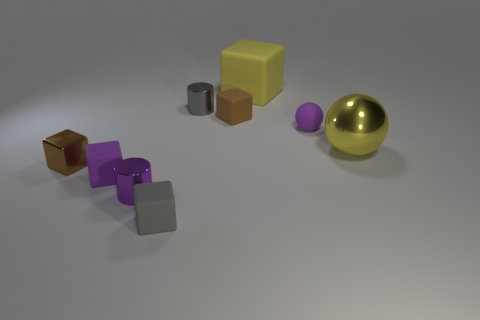Subtract all tiny purple rubber cubes. How many cubes are left? 4 Subtract all yellow blocks. How many blocks are left? 4 Subtract all blue blocks. Subtract all gray cylinders. How many blocks are left? 5 Add 1 brown shiny blocks. How many objects exist? 10 Subtract all cylinders. How many objects are left? 7 Subtract 0 red balls. How many objects are left? 9 Subtract all small cylinders. Subtract all small matte balls. How many objects are left? 6 Add 8 big spheres. How many big spheres are left? 9 Add 7 large yellow balls. How many large yellow balls exist? 8 